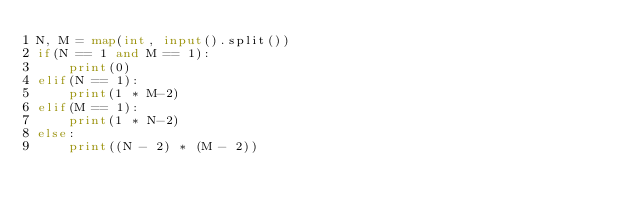Convert code to text. <code><loc_0><loc_0><loc_500><loc_500><_Python_>N, M = map(int, input().split())
if(N == 1 and M == 1):
    print(0)
elif(N == 1):
    print(1 * M-2)
elif(M == 1):
    print(1 * N-2)
else:
    print((N - 2) * (M - 2))</code> 